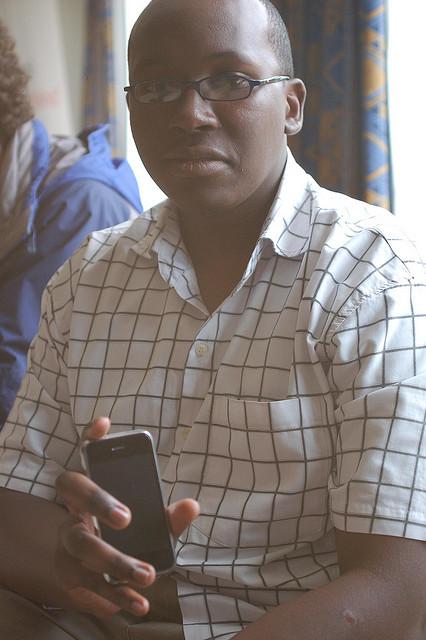What is behind the man?
Write a very short answer. Curtains. Intelligent being holding an intelligent device?
Write a very short answer. Yes. Is the cell phone a smartphone or a feature phone?
Quick response, please. Smartphone. What is the man wearing on his face?
Quick response, please. Glasses. 